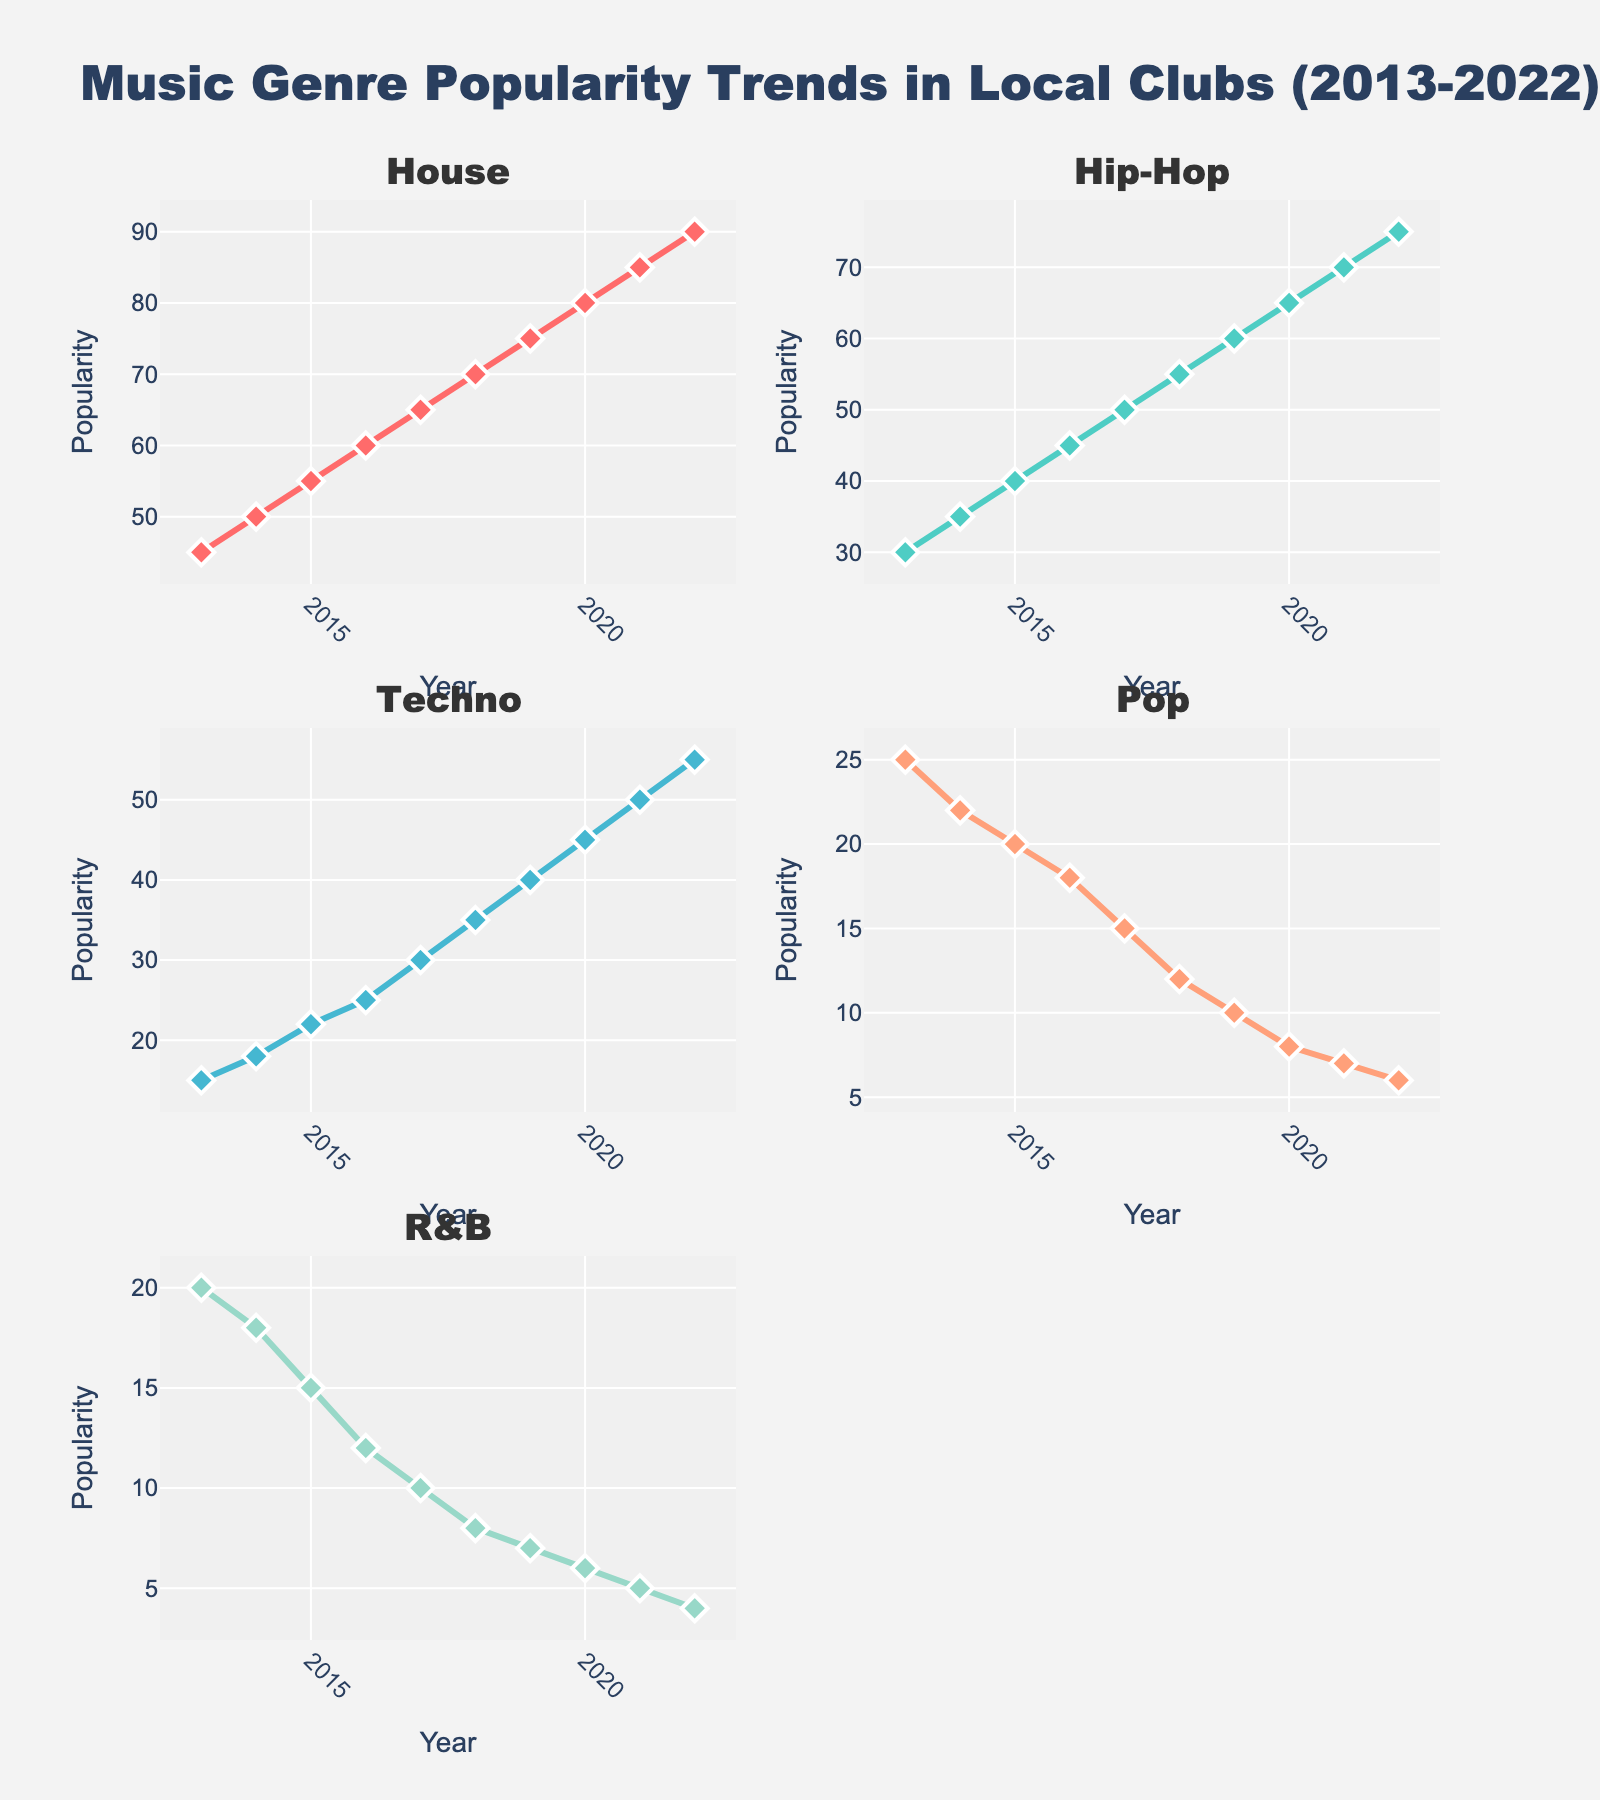Which Wi-Fi standard has the highest maximum speed? To find the Wi-Fi standard with the highest maximum speed, look at the top of the Bar chart or the hover text in the Log Scale line chart. The standard `802.11ax` has the highest value of 9608 Mbps.
Answer: 802.11ax Which Wi-Fi standard has the lowest maximum speed? To find the Wi-Fi standard with the lowest maximum speed, look at the bottom of the Bar chart or the hover text in the Log Scale line chart. The standard `802.11b` has the lowest value of 11 Mbps.
Answer: 802.11b What is the maximum speed of the 802.11n standard? Check the `802.11n` bar in the bar chart or the line marker in the Log Scale line chart, which shows a hover text value of 600 Mbps.
Answer: 600 Mbps How many Wi-Fi standards have a maximum speed above 1000 Mbps? Look at the y-axis values of both the bar chart and log-scale chart, focusing on values above 1000 Mbps. There are two standards: `802.11ac` (3466 Mbps) and `802.11ax` (9608 Mbps).
Answer: 2 What is the difference in maximum speed between 802.11g and 802.11ac? Identify the maximum speeds of `802.11g` (54 Mbps) and `802.11ac` (3466 Mbps) from the chart. The difference is calculated as `3466 - 54 = 3412 Mbps`.
Answer: 3412 Mbps Which two Wi-Fi standards have the same maximum speed? From the bar chart, the two standards `802.11a` and `802.11g` have the same maximum speed of 54 Mbps.
Answer: 802.11a and 802.11g What is the average maximum speed of all the Wi-Fi standards? Sum the maximum speeds from the data: `54 + 11 + 54 + 600 + 3466 + 9608` and divide by the number of standards (6). The sum is `13793`, so the average is `13793 / 6 ≈ 2298.83 Mbps`.
Answer: 2298.83 Mbps What is the ratio of the maximum speed between 802.11ac and 802.11b? Identify the maximum speeds of `802.11ac` (3466 Mbps) and `802.11b` (11 Mbps) from the chart. The ratio is calculated as `3466 / 11 ≈ 315.09`.
Answer: 315.09 Between which two standards does the most significant speed increase occur? Look at the bar chart's height and the difference in the Log Scale chart, the most significant increase is between `802.11ac` (3466 Mbps) and `802.11ax` (9608 Mbps) with an increase of `9608 - 3466 = 6142 Mbps`.
Answer: 802.11ac and 802.11ax How does the logarithmic scale help in visualizing the data? The logarithmic scale transforms the wide range of speeds into a more manageable scale, making it easier to compare standards with vastly different speeds and observe the growth trends.
Answer: Better comparison and trend visualization 